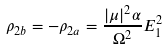<formula> <loc_0><loc_0><loc_500><loc_500>\rho _ { 2 b } = - \rho _ { 2 a } = \frac { | \mu | ^ { 2 } \alpha } { \Omega ^ { 2 } } E _ { 1 } ^ { 2 }</formula> 